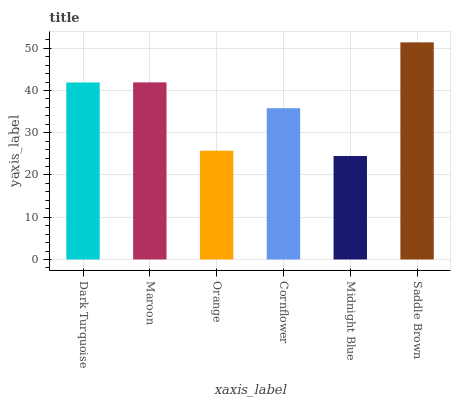Is Maroon the minimum?
Answer yes or no. No. Is Maroon the maximum?
Answer yes or no. No. Is Maroon greater than Dark Turquoise?
Answer yes or no. Yes. Is Dark Turquoise less than Maroon?
Answer yes or no. Yes. Is Dark Turquoise greater than Maroon?
Answer yes or no. No. Is Maroon less than Dark Turquoise?
Answer yes or no. No. Is Dark Turquoise the high median?
Answer yes or no. Yes. Is Cornflower the low median?
Answer yes or no. Yes. Is Orange the high median?
Answer yes or no. No. Is Orange the low median?
Answer yes or no. No. 